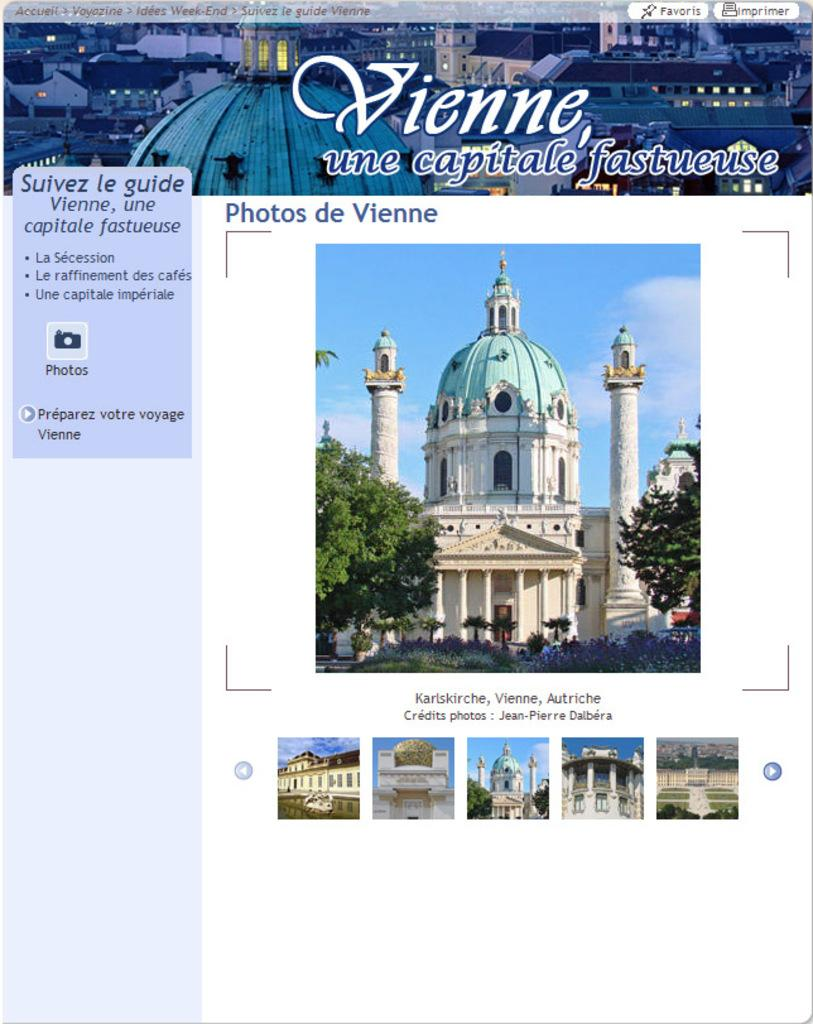What type of content is displayed in the image? The image contains a web site page. What kind of images can be seen on the web site page? There are pictures of buildings and trees on the web site page. Is there any written content on the web site page? Yes, there is text written on the web site page. What is the main title or heading on the web site page? There is a heading at the top of the web site page, and it features pictures of buildings. Can you describe the content of the heading? The heading contains pictures of buildings. How many letters are required to spell the name of the building in the heading? There is no need to spell the name of the building in the heading, as the question is not relevant to the image. 